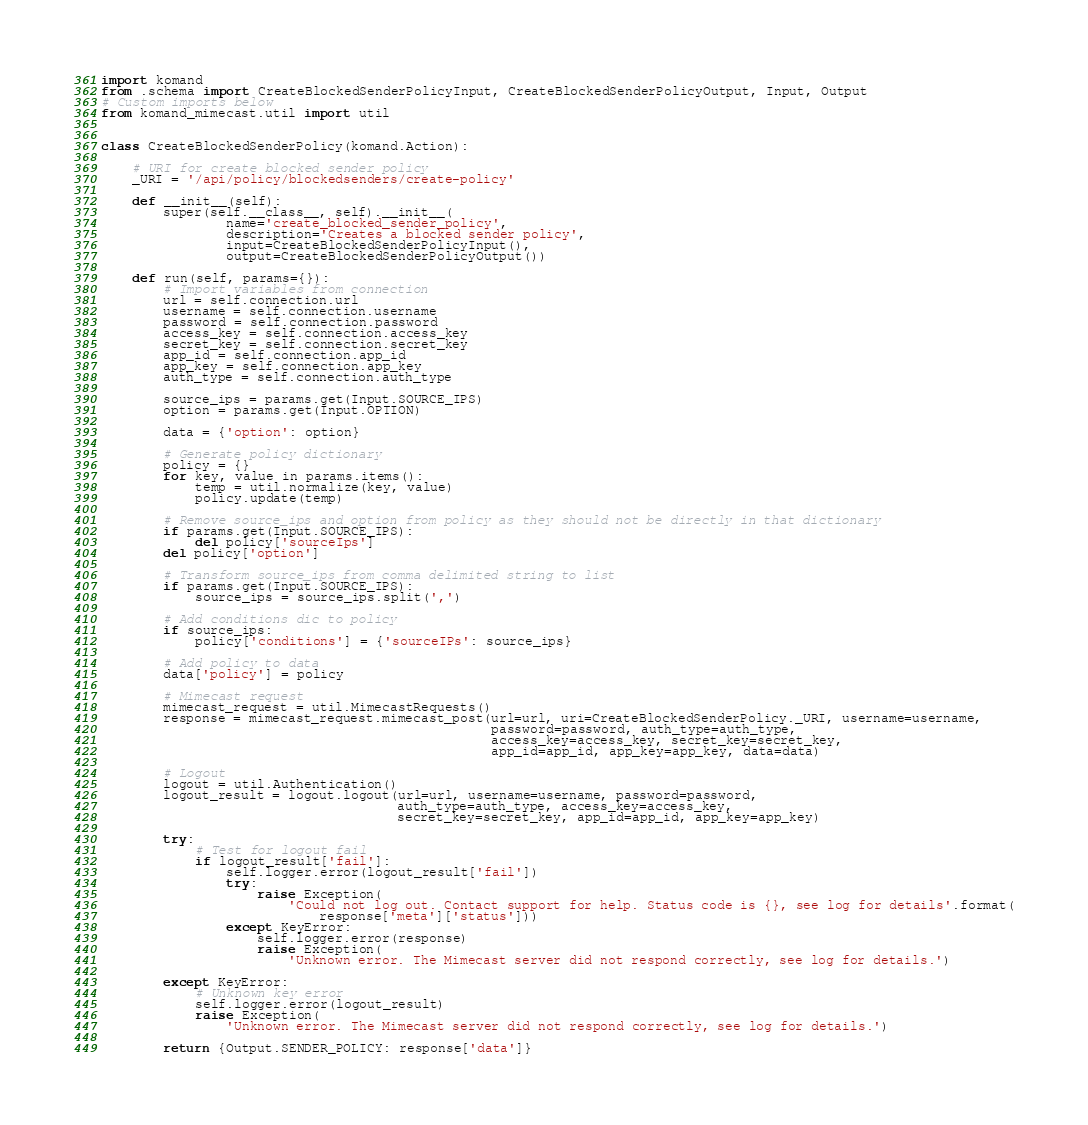Convert code to text. <code><loc_0><loc_0><loc_500><loc_500><_Python_>import komand
from .schema import CreateBlockedSenderPolicyInput, CreateBlockedSenderPolicyOutput, Input, Output
# Custom imports below
from komand_mimecast.util import util


class CreateBlockedSenderPolicy(komand.Action):

    # URI for create blocked sender policy
    _URI = '/api/policy/blockedsenders/create-policy'

    def __init__(self):
        super(self.__class__, self).__init__(
                name='create_blocked_sender_policy',
                description='Creates a blocked sender policy',
                input=CreateBlockedSenderPolicyInput(),
                output=CreateBlockedSenderPolicyOutput())

    def run(self, params={}):
        # Import variables from connection
        url = self.connection.url
        username = self.connection.username
        password = self.connection.password
        access_key = self.connection.access_key
        secret_key = self.connection.secret_key
        app_id = self.connection.app_id
        app_key = self.connection.app_key
        auth_type = self.connection.auth_type

        source_ips = params.get(Input.SOURCE_IPS)
        option = params.get(Input.OPTION)

        data = {'option': option}

        # Generate policy dictionary
        policy = {}
        for key, value in params.items():
            temp = util.normalize(key, value)
            policy.update(temp)

        # Remove source_ips and option from policy as they should not be directly in that dictionary
        if params.get(Input.SOURCE_IPS):
            del policy['sourceIps']
        del policy['option']

        # Transform source_ips from comma delimited string to list
        if params.get(Input.SOURCE_IPS):
            source_ips = source_ips.split(',')

        # Add conditions dic to policy
        if source_ips:
            policy['conditions'] = {'sourceIPs': source_ips}

        # Add policy to data
        data['policy'] = policy

        # Mimecast request
        mimecast_request = util.MimecastRequests()
        response = mimecast_request.mimecast_post(url=url, uri=CreateBlockedSenderPolicy._URI, username=username,
                                                  password=password, auth_type=auth_type,
                                                  access_key=access_key, secret_key=secret_key,
                                                  app_id=app_id, app_key=app_key, data=data)

        # Logout
        logout = util.Authentication()
        logout_result = logout.logout(url=url, username=username, password=password,
                                      auth_type=auth_type, access_key=access_key,
                                      secret_key=secret_key, app_id=app_id, app_key=app_key)

        try:
            # Test for logout fail
            if logout_result['fail']:
                self.logger.error(logout_result['fail'])
                try:
                    raise Exception(
                        'Could not log out. Contact support for help. Status code is {}, see log for details'.format(
                            response['meta']['status']))
                except KeyError:
                    self.logger.error(response)
                    raise Exception(
                        'Unknown error. The Mimecast server did not respond correctly, see log for details.')

        except KeyError:
            # Unknown key error
            self.logger.error(logout_result)
            raise Exception(
                'Unknown error. The Mimecast server did not respond correctly, see log for details.')

        return {Output.SENDER_POLICY: response['data']}
</code> 